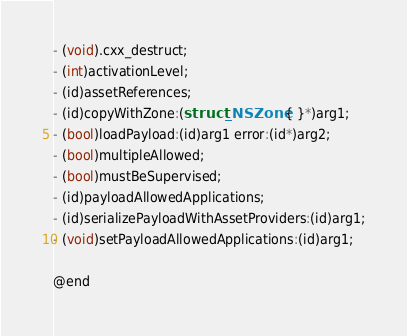Convert code to text. <code><loc_0><loc_0><loc_500><loc_500><_C_>
- (void).cxx_destruct;
- (int)activationLevel;
- (id)assetReferences;
- (id)copyWithZone:(struct _NSZone { }*)arg1;
- (bool)loadPayload:(id)arg1 error:(id*)arg2;
- (bool)multipleAllowed;
- (bool)mustBeSupervised;
- (id)payloadAllowedApplications;
- (id)serializePayloadWithAssetProviders:(id)arg1;
- (void)setPayloadAllowedApplications:(id)arg1;

@end
</code> 